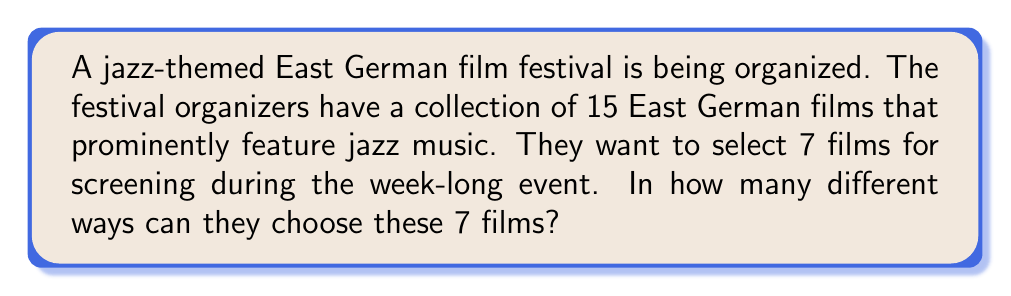Show me your answer to this math problem. To solve this problem, we need to use the concept of combinations. We are selecting a subset of films from a larger set, where the order of selection doesn't matter (as we're just creating a list of films to be shown, not determining the order in which they'll be screened).

The formula for combinations is:

$$ C(n,r) = \frac{n!}{r!(n-r)!} $$

Where:
- $n$ is the total number of items to choose from (in this case, 15 films)
- $r$ is the number of items being chosen (in this case, 7 films)

Let's substitute these values into our formula:

$$ C(15,7) = \frac{15!}{7!(15-7)!} = \frac{15!}{7!8!} $$

Now, let's calculate this step-by-step:

1) $15! = 1,307,674,368,000$
2) $7! = 5,040$
3) $8! = 40,320$

Substituting these values:

$$ \frac{1,307,674,368,000}{5,040 \times 40,320} = \frac{1,307,674,368,000}{203,212,800} = 6,435 $$

Therefore, there are 6,435 different ways to select 7 films from a collection of 15 films.
Answer: 6,435 combinations 